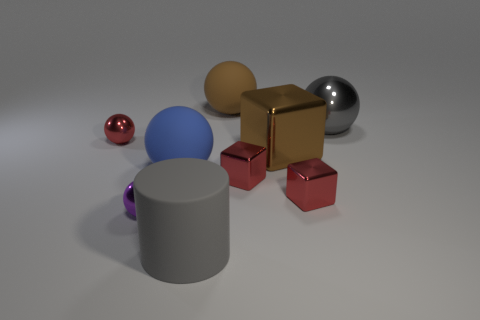Subtract 2 balls. How many balls are left? 3 Subtract all gray balls. How many balls are left? 4 Subtract all small red spheres. How many spheres are left? 4 Subtract all cyan balls. Subtract all cyan cylinders. How many balls are left? 5 Subtract all cylinders. How many objects are left? 8 Add 2 big gray cylinders. How many big gray cylinders are left? 3 Add 8 big gray balls. How many big gray balls exist? 9 Subtract 1 brown spheres. How many objects are left? 8 Subtract all matte objects. Subtract all big gray cylinders. How many objects are left? 5 